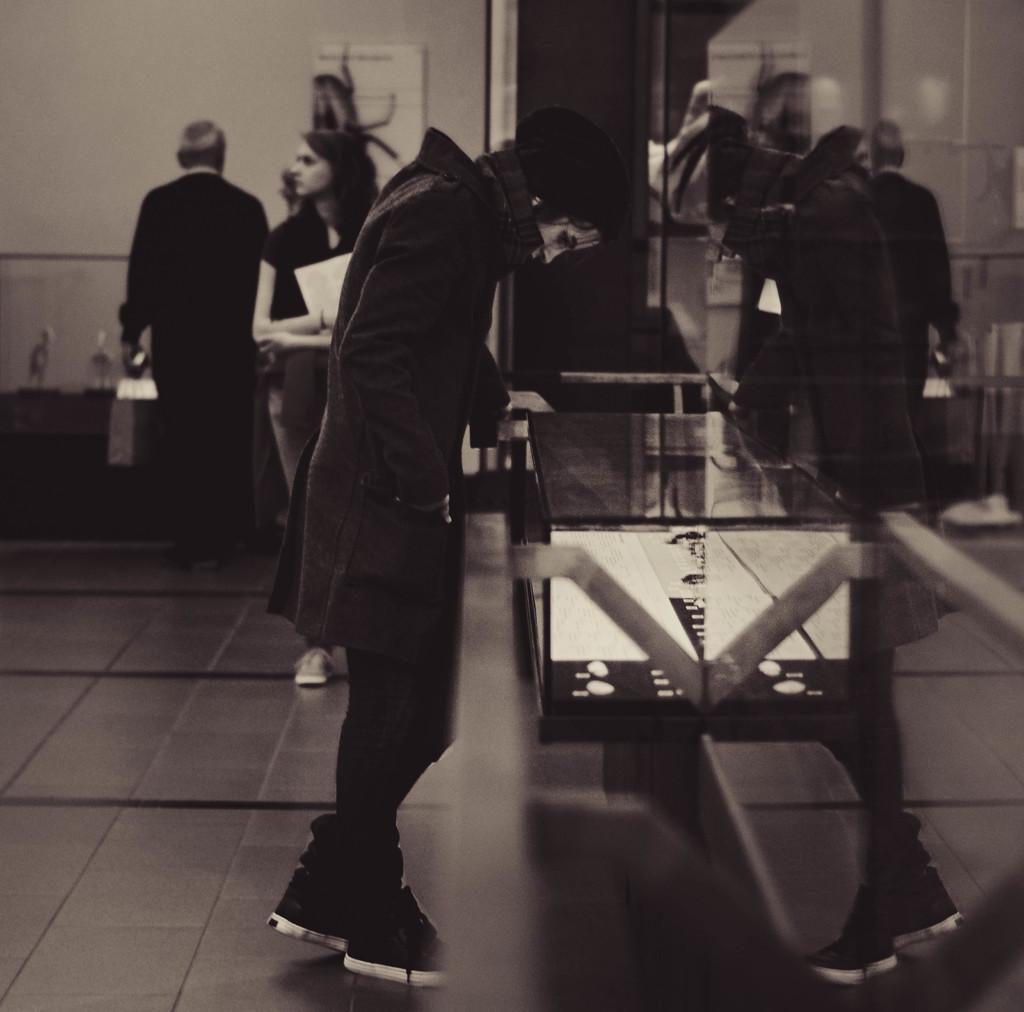Could you give a brief overview of what you see in this image? In this image I can see group of people standing. In the background I can see the person holding few papers and the image is in black and white. 